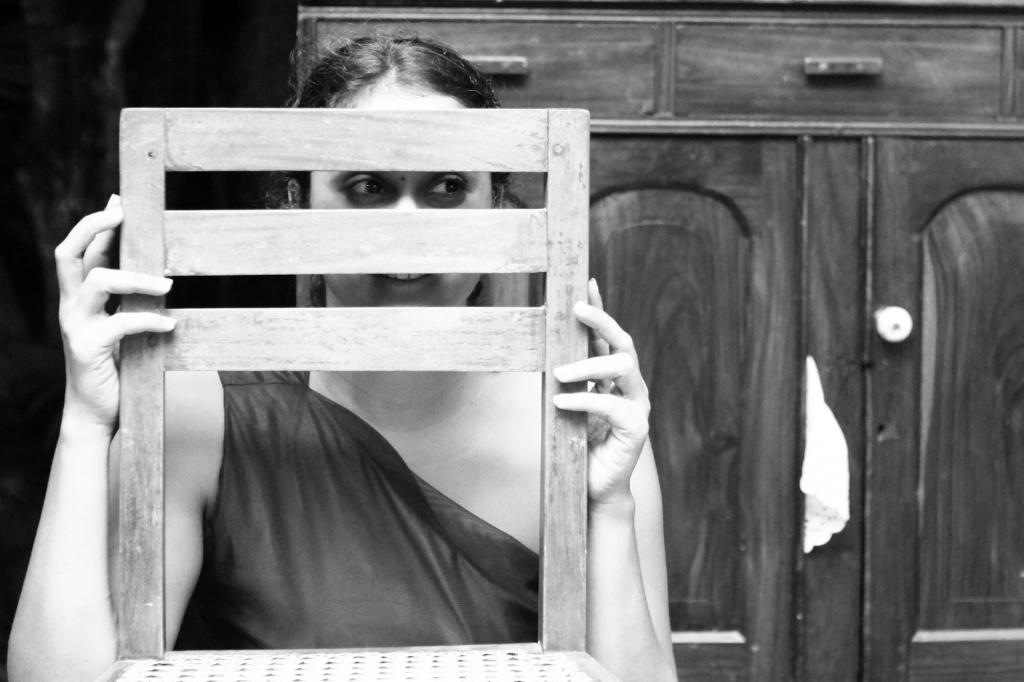What is the primary subject of the image? There is a person in the image. Can you describe the person's position in the image? The person is sitting on a chair with their back facing the viewer. What can be seen in the background of the image? There are cupboards in the background of the image. What is the color scheme of the image? The image is in black and white. How many times does the person in the image crack a bit while sitting on the chair? There is no indication in the image that the person is cracking a bit or engaging in any such activity. 